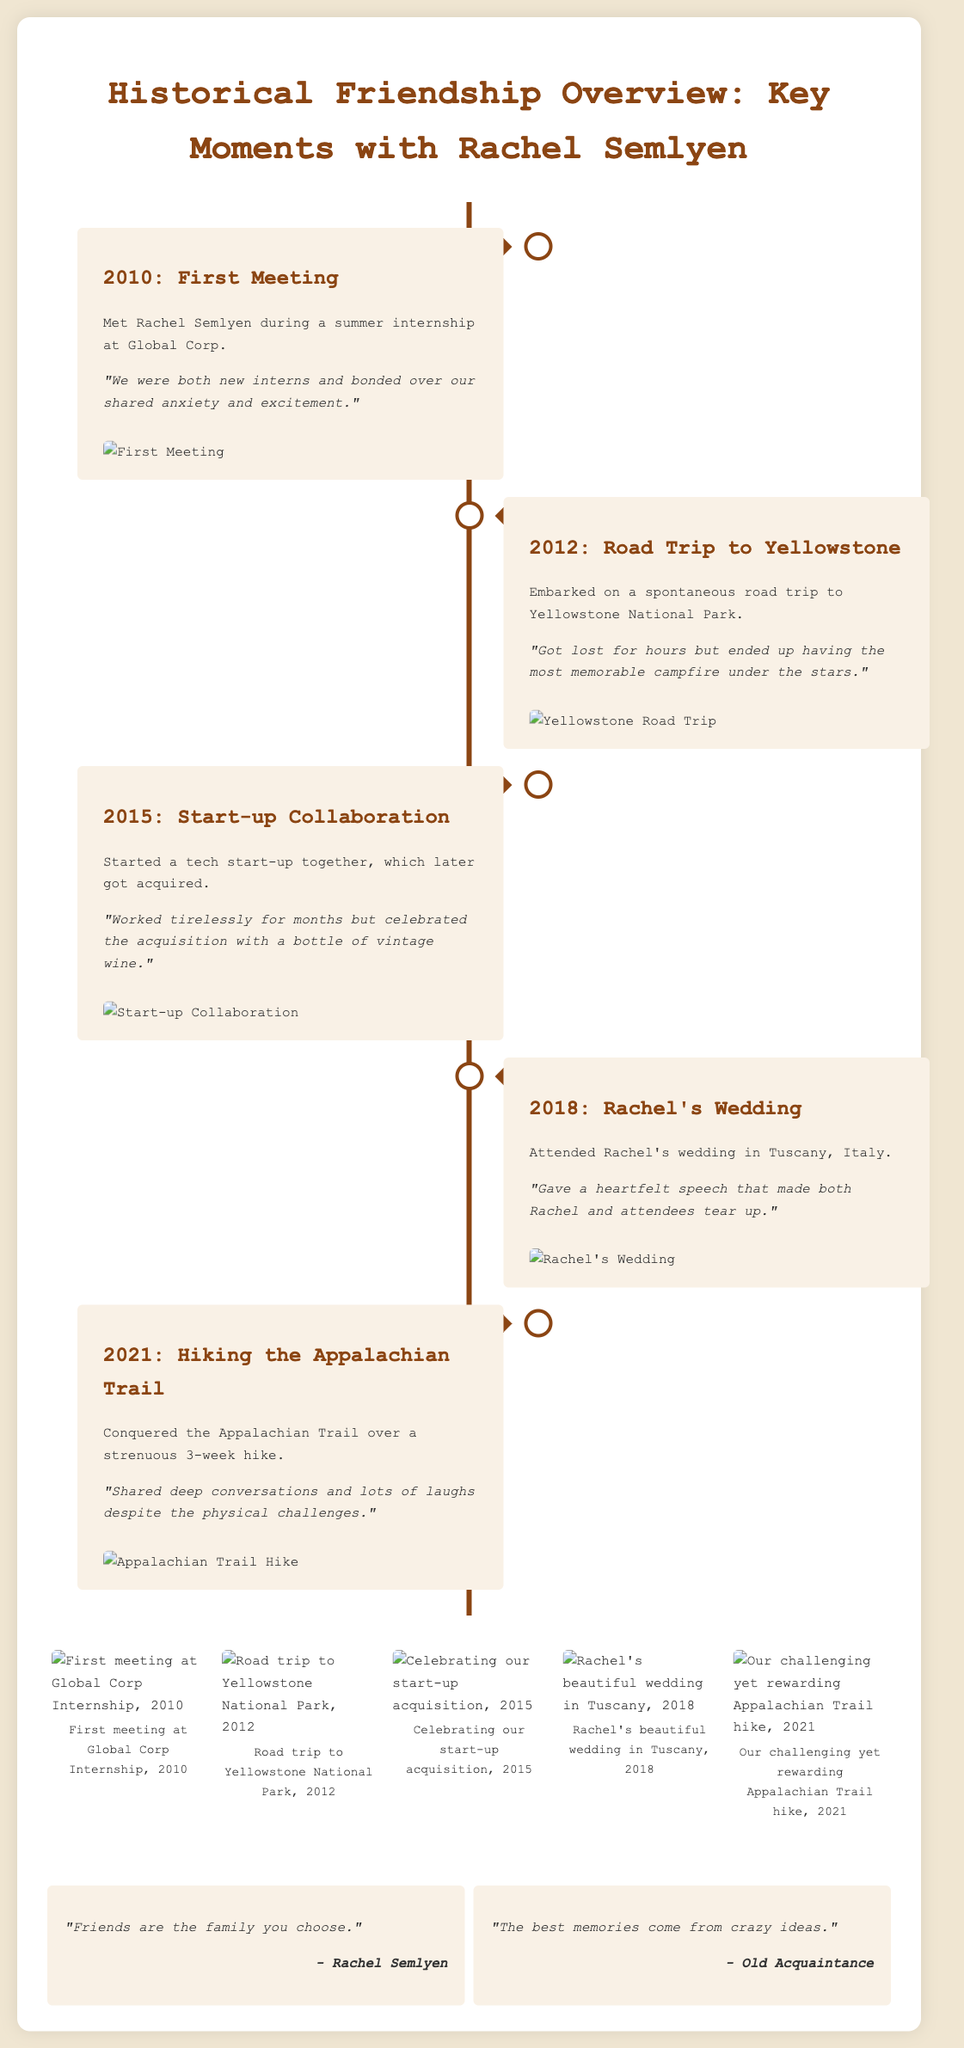What year did you first meet Rachel? The document states that the first meeting occurred in 2010.
Answer: 2010 What was the location of Rachel's wedding? The document mentions that Rachel's wedding took place in Tuscany, Italy.
Answer: Tuscany How long was the hike on the Appalachian Trail? The document indicates it was a strenuous 3-week hike.
Answer: 3 weeks What significant event happened in 2015? According to the document, in 2015, there was a start-up collaboration that later got acquired.
Answer: Start-up Collaboration What did Rachel say about friends? The document quotes Rachel saying, "Friends are the family you choose."
Answer: "Friends are the family you choose." What memorable activity was shared during the 2012 road trip? The document describes a memorable campfire under the stars during the road trip to Yellowstone.
Answer: Campfire under the stars Which year did you celebrate an acquisition? The acquisition celebration occurred in 2015, as stated in the document.
Answer: 2015 What is highlighted as a key moment in 2021? The document highlights conquering the Appalachian Trail as a key moment in 2021.
Answer: Appalachian Trail Hike 